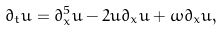<formula> <loc_0><loc_0><loc_500><loc_500>\partial _ { t } u = \partial _ { x } ^ { 5 } u - 2 u \partial _ { x } u + \omega \partial _ { x } u ,</formula> 